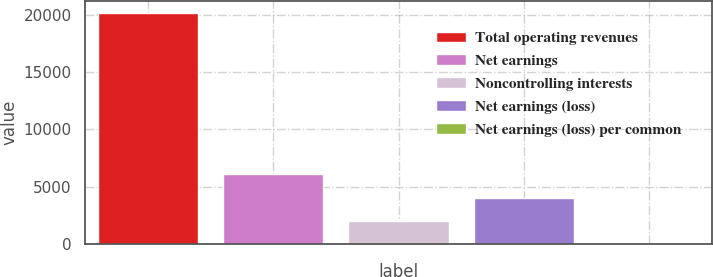Convert chart to OTSL. <chart><loc_0><loc_0><loc_500><loc_500><bar_chart><fcel>Total operating revenues<fcel>Net earnings<fcel>Noncontrolling interests<fcel>Net earnings (loss)<fcel>Net earnings (loss) per common<nl><fcel>20213<fcel>6066.67<fcel>2024.85<fcel>4045.76<fcel>3.94<nl></chart> 